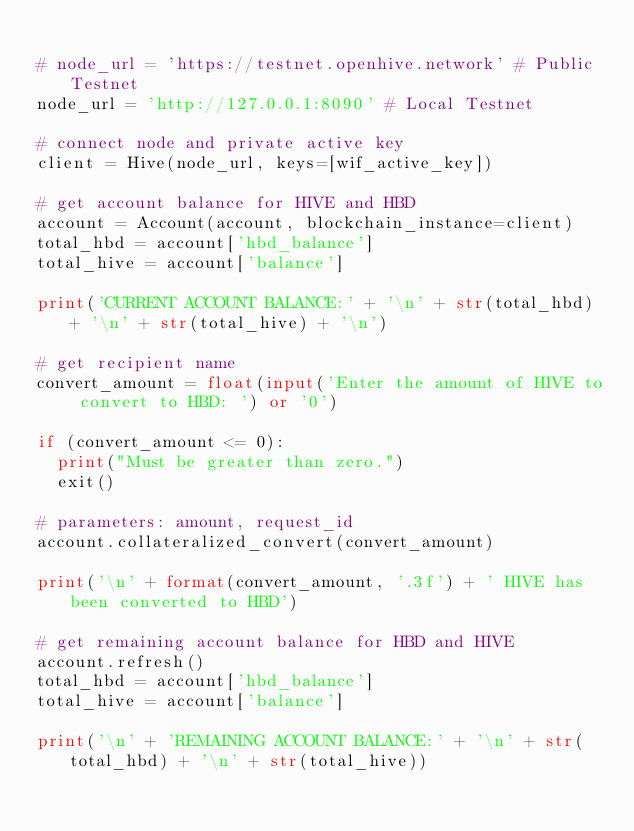Convert code to text. <code><loc_0><loc_0><loc_500><loc_500><_Python_>
# node_url = 'https://testnet.openhive.network' # Public Testnet
node_url = 'http://127.0.0.1:8090' # Local Testnet

# connect node and private active key
client = Hive(node_url, keys=[wif_active_key])

# get account balance for HIVE and HBD
account = Account(account, blockchain_instance=client)
total_hbd = account['hbd_balance']
total_hive = account['balance']

print('CURRENT ACCOUNT BALANCE:' + '\n' + str(total_hbd) + '\n' + str(total_hive) + '\n')

# get recipient name
convert_amount = float(input('Enter the amount of HIVE to convert to HBD: ') or '0')

if (convert_amount <= 0):
  print("Must be greater than zero.")
  exit()

# parameters: amount, request_id
account.collateralized_convert(convert_amount)

print('\n' + format(convert_amount, '.3f') + ' HIVE has been converted to HBD')

# get remaining account balance for HBD and HIVE
account.refresh()
total_hbd = account['hbd_balance']
total_hive = account['balance']

print('\n' + 'REMAINING ACCOUNT BALANCE:' + '\n' + str(total_hbd) + '\n' + str(total_hive))

</code> 